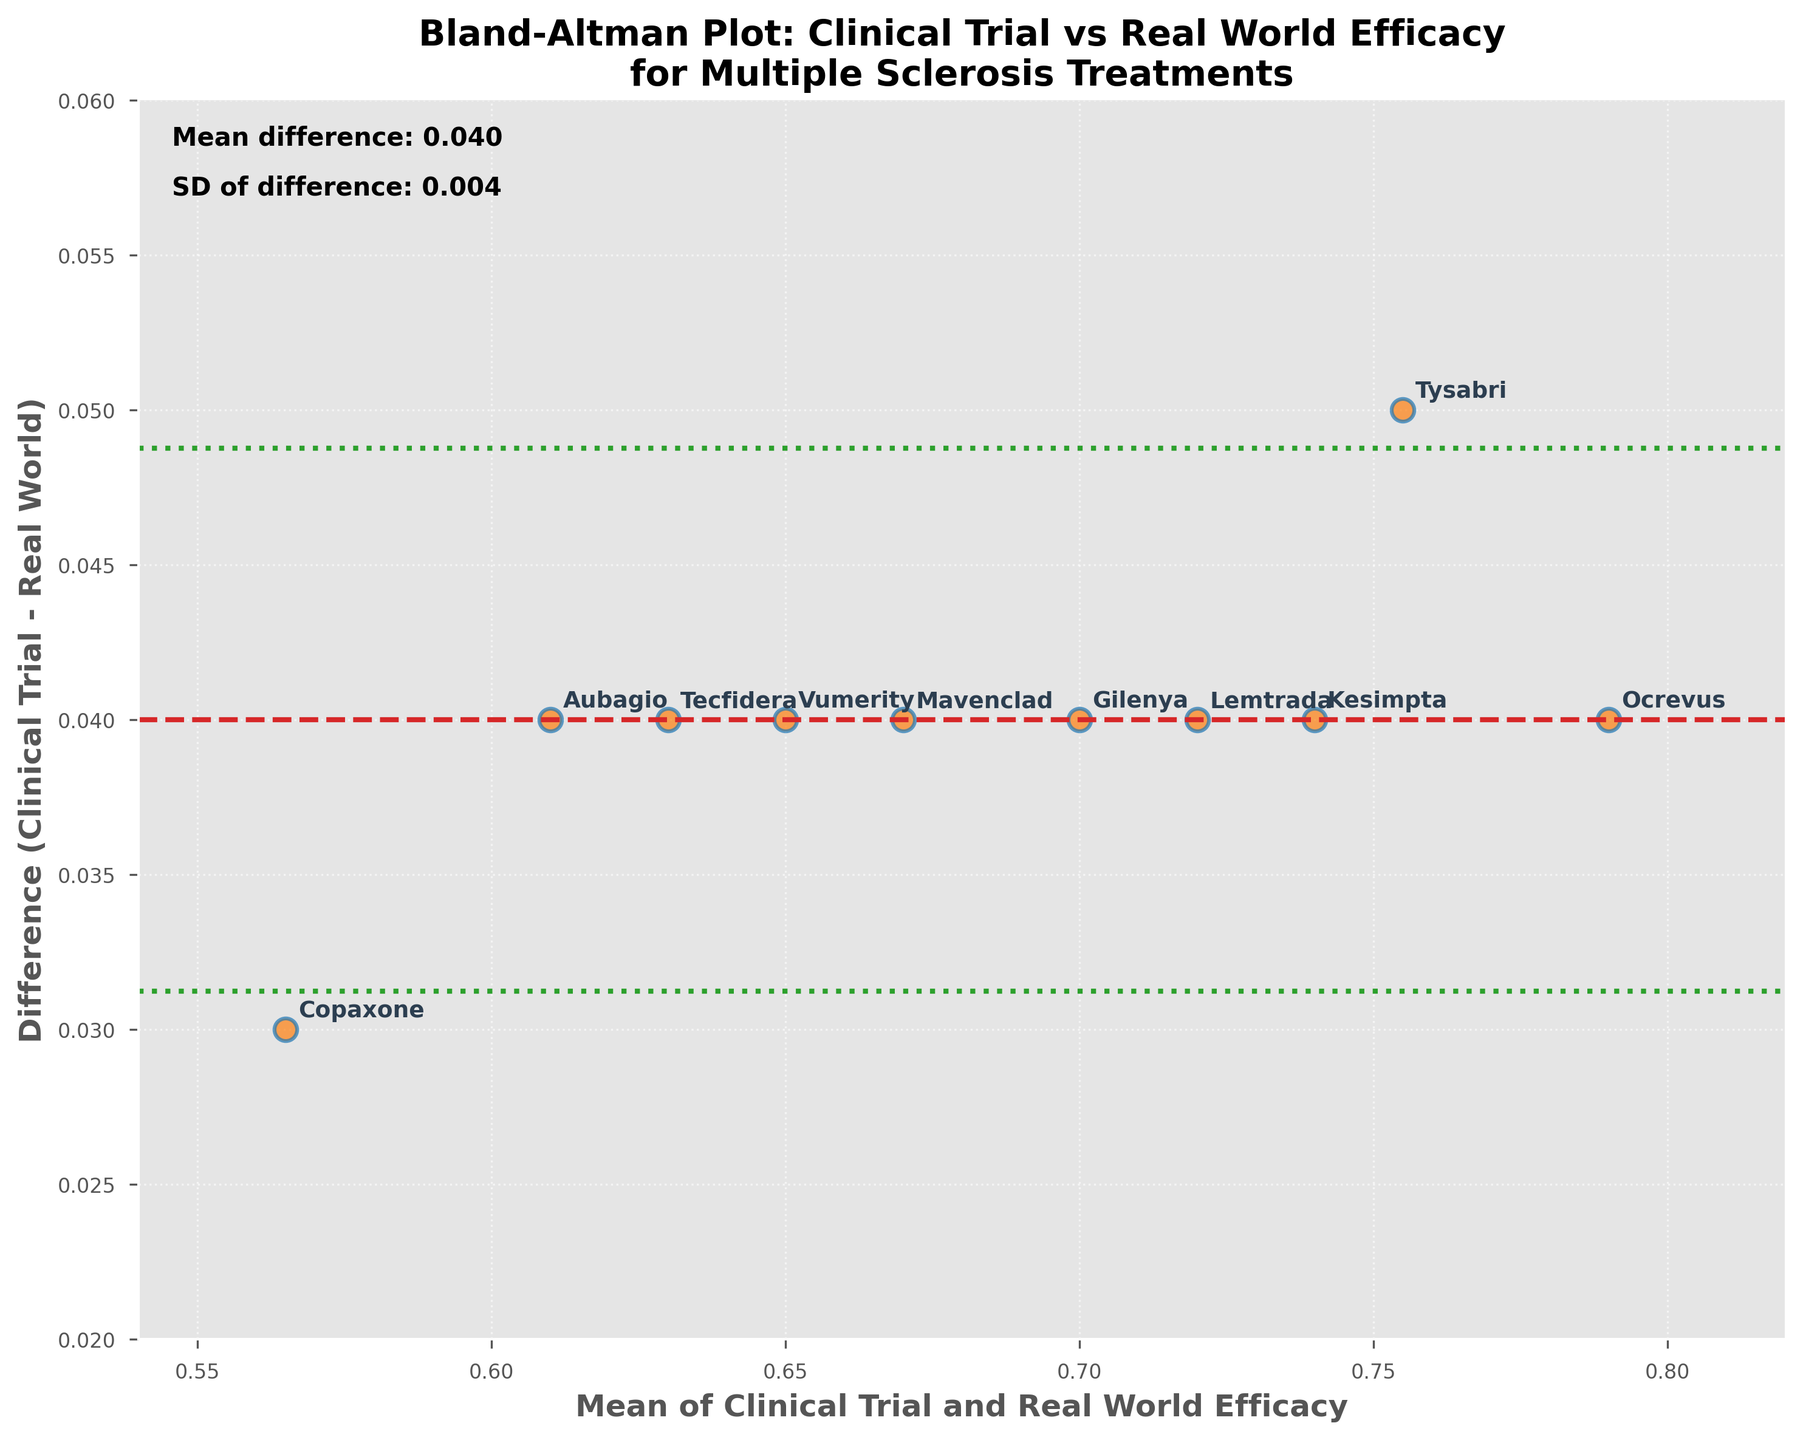How many data points are plotted in the figure? By counting the number of points in the scatter plot, or by referring to the number of drugs listed, we can determine the total number of data points.
Answer: 10 What does the horizontal dashed line represent? The horizontal dashed line represents the mean difference between the clinical trial and real-world efficacy measurements.
Answer: Mean difference Which drug shows the smallest difference between clinical trial and real-world efficacy? By comparing the vertical positions of the points, the drug with the lowest difference will be the one nearest the x-axis (y=0). This is Vumerity.
Answer: Vumerity What are the upper and lower limits of agreement in the plot? The upper and lower limits of agreement are represented by the dotted lines at \( \text{Mean Difference} \pm 1.96 \times \text{Standard Deviation} \). Based on the annotations in the plot, these limits can be directly observed.
Answer: Upper: ~0.046, Lower: ~0.026 What does it mean if a drug's point is above the mean difference line? A point above the mean difference line indicates that the clinical trial efficacy measurement is higher than the real-world efficacy measurement for that drug.
Answer: Clinical trial > Real-world Which drug has the highest average efficacy between clinical trials and real-world studies? To find the drug with the highest average efficacy, identify the point with the highest x-axis value as the x-axis represents the mean efficacy of both measurements. This is Ocrevus.
Answer: Ocrevus Are there any drugs that fall outside the limits of agreement? Determine if any points lie outside the dotted lines representing the ±1.96 SD limits.
Answer: No Is the mean difference positive or negative? The direction of the mean difference line (dashed) indicates if it is positive or negative relative to the zero line.
Answer: Positive What can be inferred if almost all points are within the limits of agreement? If almost all points lie within ±1.96 SD limits, it suggests good agreement between clinical trial and real-world efficacy measurements.
Answer: Good agreement Which range on the x-axis shows the highest concentration of points? By observing where points are most densely populated along the x-axis, one can see the range.
Answer: 0.66 - 0.74 